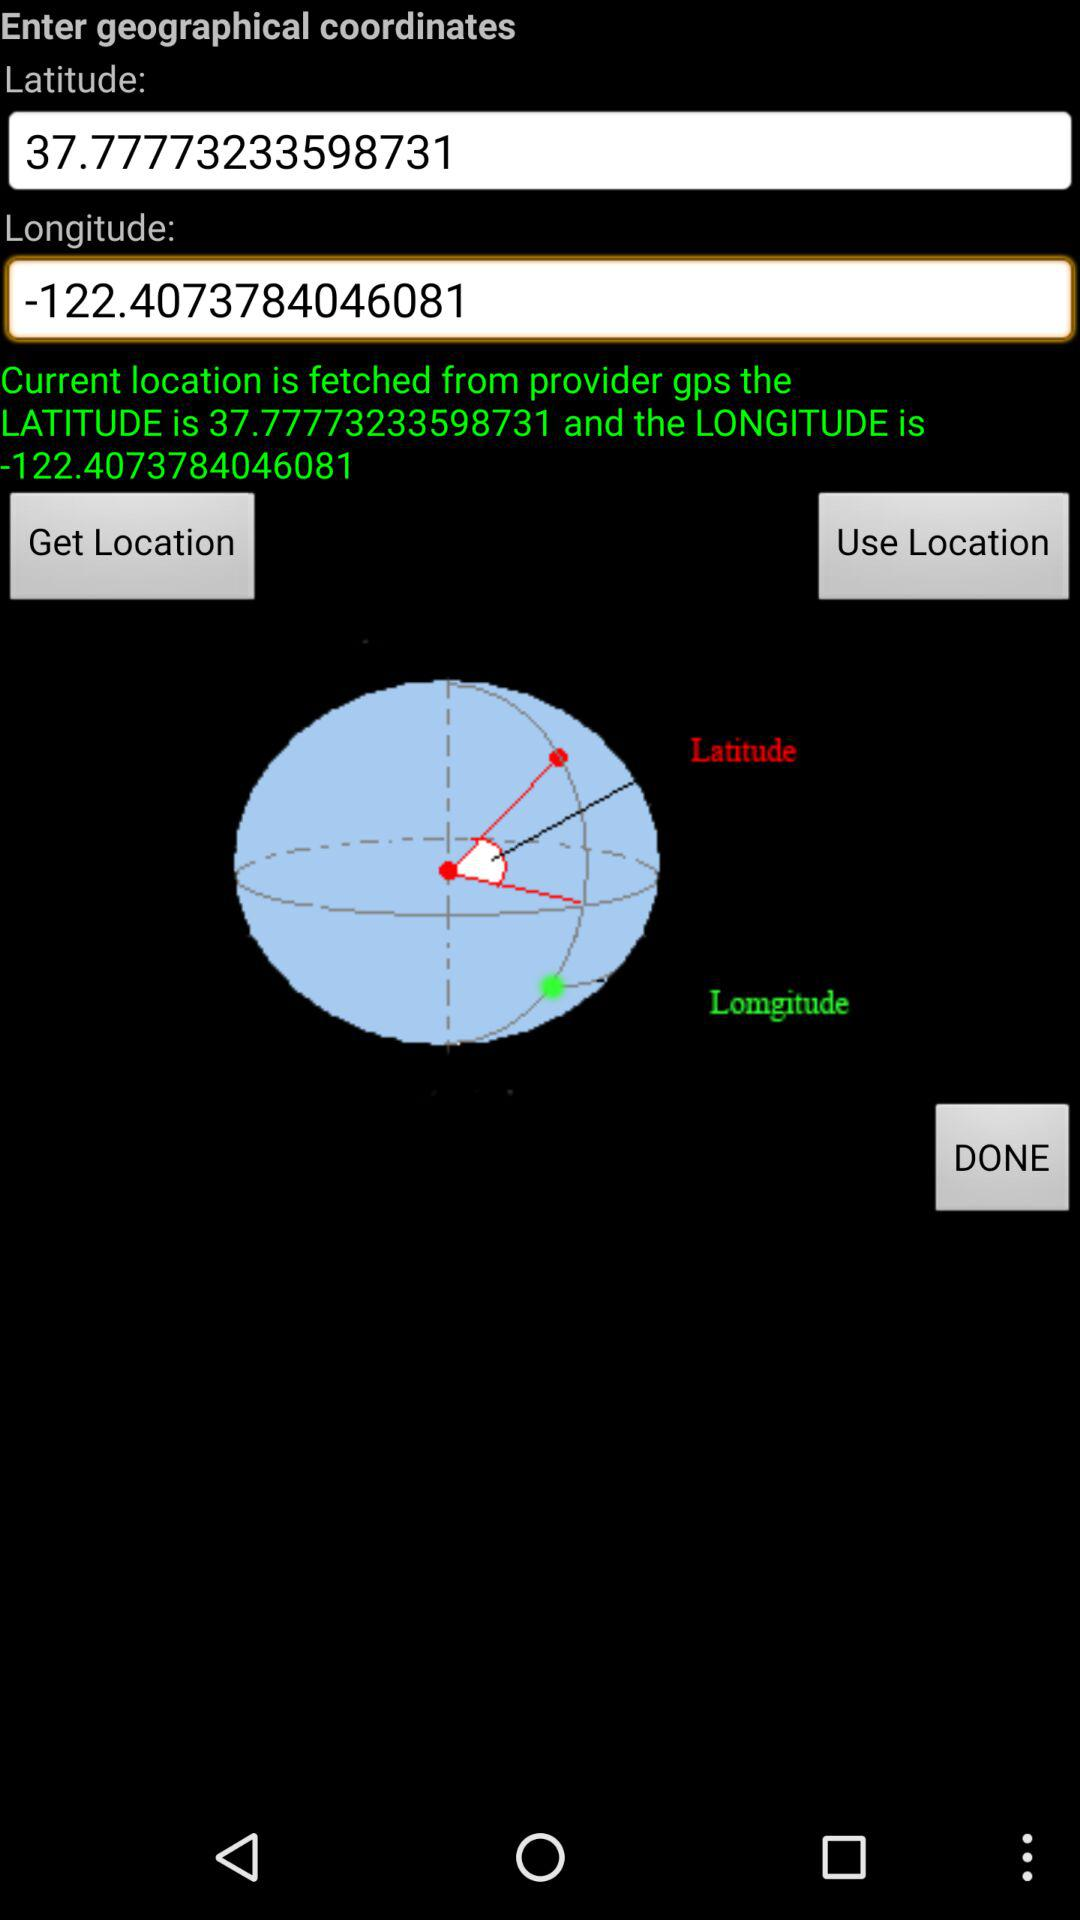What is given latitude? The given latitude is 37.77773233598731. 